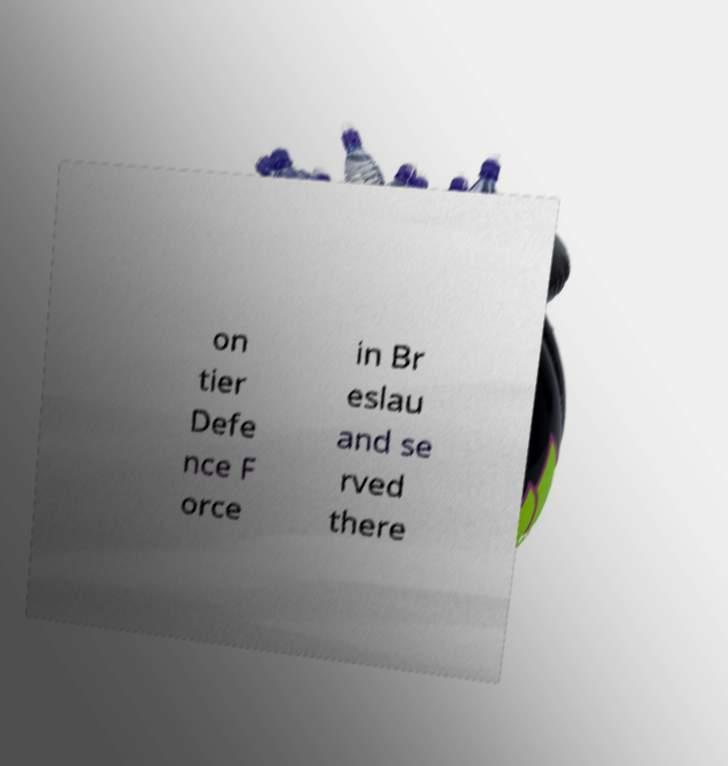What messages or text are displayed in this image? I need them in a readable, typed format. on tier Defe nce F orce in Br eslau and se rved there 